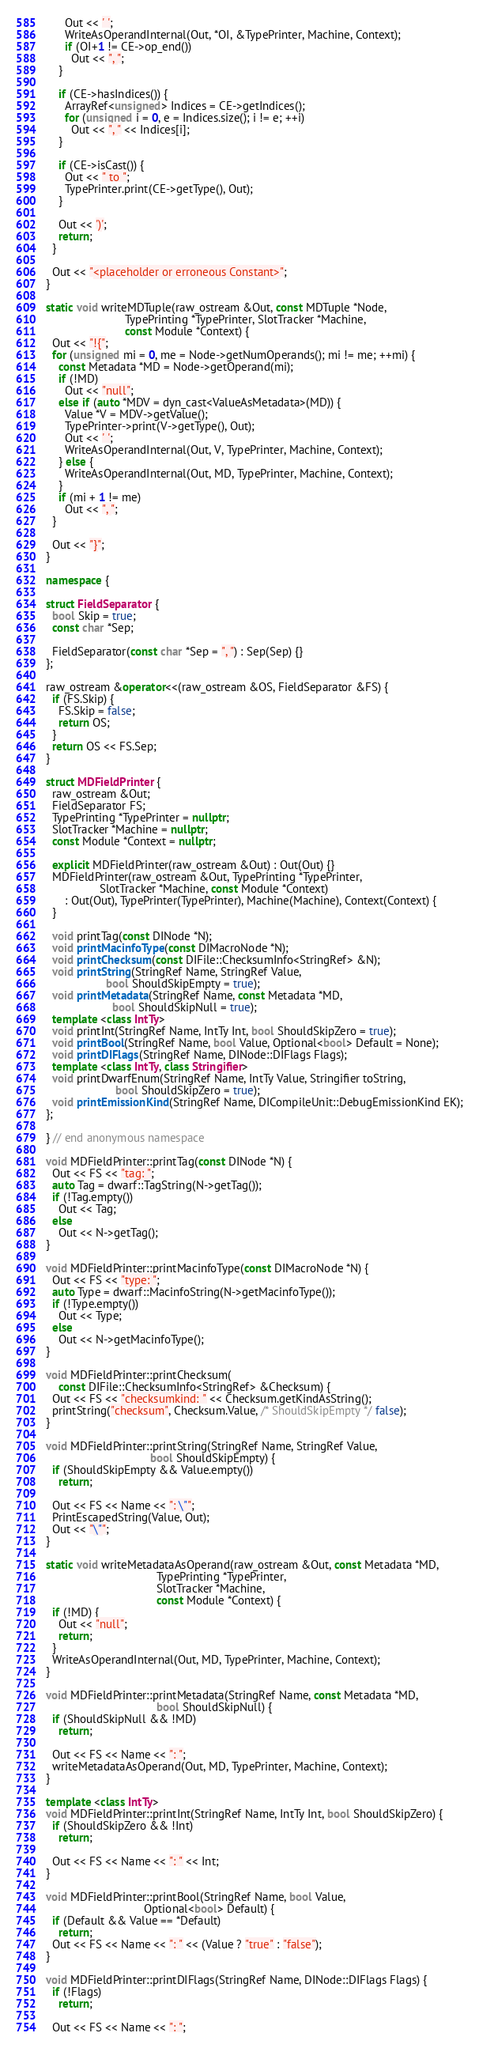<code> <loc_0><loc_0><loc_500><loc_500><_C++_>      Out << ' ';
      WriteAsOperandInternal(Out, *OI, &TypePrinter, Machine, Context);
      if (OI+1 != CE->op_end())
        Out << ", ";
    }

    if (CE->hasIndices()) {
      ArrayRef<unsigned> Indices = CE->getIndices();
      for (unsigned i = 0, e = Indices.size(); i != e; ++i)
        Out << ", " << Indices[i];
    }

    if (CE->isCast()) {
      Out << " to ";
      TypePrinter.print(CE->getType(), Out);
    }

    Out << ')';
    return;
  }

  Out << "<placeholder or erroneous Constant>";
}

static void writeMDTuple(raw_ostream &Out, const MDTuple *Node,
                         TypePrinting *TypePrinter, SlotTracker *Machine,
                         const Module *Context) {
  Out << "!{";
  for (unsigned mi = 0, me = Node->getNumOperands(); mi != me; ++mi) {
    const Metadata *MD = Node->getOperand(mi);
    if (!MD)
      Out << "null";
    else if (auto *MDV = dyn_cast<ValueAsMetadata>(MD)) {
      Value *V = MDV->getValue();
      TypePrinter->print(V->getType(), Out);
      Out << ' ';
      WriteAsOperandInternal(Out, V, TypePrinter, Machine, Context);
    } else {
      WriteAsOperandInternal(Out, MD, TypePrinter, Machine, Context);
    }
    if (mi + 1 != me)
      Out << ", ";
  }

  Out << "}";
}

namespace {

struct FieldSeparator {
  bool Skip = true;
  const char *Sep;

  FieldSeparator(const char *Sep = ", ") : Sep(Sep) {}
};

raw_ostream &operator<<(raw_ostream &OS, FieldSeparator &FS) {
  if (FS.Skip) {
    FS.Skip = false;
    return OS;
  }
  return OS << FS.Sep;
}

struct MDFieldPrinter {
  raw_ostream &Out;
  FieldSeparator FS;
  TypePrinting *TypePrinter = nullptr;
  SlotTracker *Machine = nullptr;
  const Module *Context = nullptr;

  explicit MDFieldPrinter(raw_ostream &Out) : Out(Out) {}
  MDFieldPrinter(raw_ostream &Out, TypePrinting *TypePrinter,
                 SlotTracker *Machine, const Module *Context)
      : Out(Out), TypePrinter(TypePrinter), Machine(Machine), Context(Context) {
  }

  void printTag(const DINode *N);
  void printMacinfoType(const DIMacroNode *N);
  void printChecksum(const DIFile::ChecksumInfo<StringRef> &N);
  void printString(StringRef Name, StringRef Value,
                   bool ShouldSkipEmpty = true);
  void printMetadata(StringRef Name, const Metadata *MD,
                     bool ShouldSkipNull = true);
  template <class IntTy>
  void printInt(StringRef Name, IntTy Int, bool ShouldSkipZero = true);
  void printBool(StringRef Name, bool Value, Optional<bool> Default = None);
  void printDIFlags(StringRef Name, DINode::DIFlags Flags);
  template <class IntTy, class Stringifier>
  void printDwarfEnum(StringRef Name, IntTy Value, Stringifier toString,
                      bool ShouldSkipZero = true);
  void printEmissionKind(StringRef Name, DICompileUnit::DebugEmissionKind EK);
};

} // end anonymous namespace

void MDFieldPrinter::printTag(const DINode *N) {
  Out << FS << "tag: ";
  auto Tag = dwarf::TagString(N->getTag());
  if (!Tag.empty())
    Out << Tag;
  else
    Out << N->getTag();
}

void MDFieldPrinter::printMacinfoType(const DIMacroNode *N) {
  Out << FS << "type: ";
  auto Type = dwarf::MacinfoString(N->getMacinfoType());
  if (!Type.empty())
    Out << Type;
  else
    Out << N->getMacinfoType();
}

void MDFieldPrinter::printChecksum(
    const DIFile::ChecksumInfo<StringRef> &Checksum) {
  Out << FS << "checksumkind: " << Checksum.getKindAsString();
  printString("checksum", Checksum.Value, /* ShouldSkipEmpty */ false);
}

void MDFieldPrinter::printString(StringRef Name, StringRef Value,
                                 bool ShouldSkipEmpty) {
  if (ShouldSkipEmpty && Value.empty())
    return;

  Out << FS << Name << ": \"";
  PrintEscapedString(Value, Out);
  Out << "\"";
}

static void writeMetadataAsOperand(raw_ostream &Out, const Metadata *MD,
                                   TypePrinting *TypePrinter,
                                   SlotTracker *Machine,
                                   const Module *Context) {
  if (!MD) {
    Out << "null";
    return;
  }
  WriteAsOperandInternal(Out, MD, TypePrinter, Machine, Context);
}

void MDFieldPrinter::printMetadata(StringRef Name, const Metadata *MD,
                                   bool ShouldSkipNull) {
  if (ShouldSkipNull && !MD)
    return;

  Out << FS << Name << ": ";
  writeMetadataAsOperand(Out, MD, TypePrinter, Machine, Context);
}

template <class IntTy>
void MDFieldPrinter::printInt(StringRef Name, IntTy Int, bool ShouldSkipZero) {
  if (ShouldSkipZero && !Int)
    return;

  Out << FS << Name << ": " << Int;
}

void MDFieldPrinter::printBool(StringRef Name, bool Value,
                               Optional<bool> Default) {
  if (Default && Value == *Default)
    return;
  Out << FS << Name << ": " << (Value ? "true" : "false");
}

void MDFieldPrinter::printDIFlags(StringRef Name, DINode::DIFlags Flags) {
  if (!Flags)
    return;

  Out << FS << Name << ": ";
</code> 